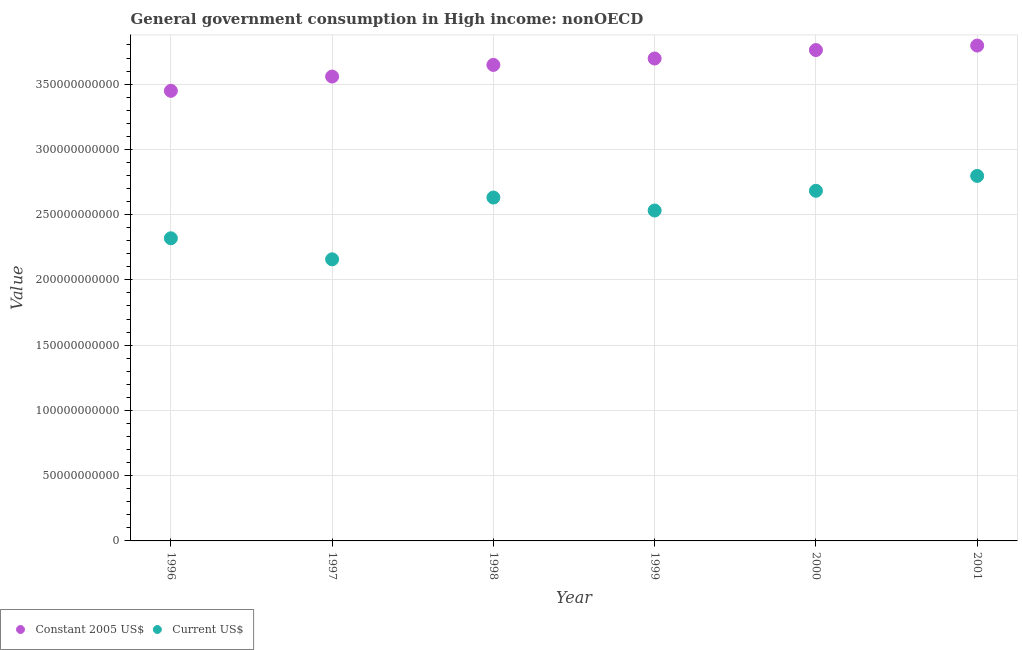Is the number of dotlines equal to the number of legend labels?
Ensure brevity in your answer.  Yes. What is the value consumed in current us$ in 1996?
Keep it short and to the point. 2.32e+11. Across all years, what is the maximum value consumed in constant 2005 us$?
Provide a succinct answer. 3.80e+11. Across all years, what is the minimum value consumed in constant 2005 us$?
Your response must be concise. 3.45e+11. In which year was the value consumed in constant 2005 us$ maximum?
Give a very brief answer. 2001. What is the total value consumed in constant 2005 us$ in the graph?
Your answer should be compact. 2.19e+12. What is the difference between the value consumed in current us$ in 1997 and that in 2001?
Offer a very short reply. -6.39e+1. What is the difference between the value consumed in constant 2005 us$ in 2001 and the value consumed in current us$ in 1996?
Your response must be concise. 1.48e+11. What is the average value consumed in current us$ per year?
Ensure brevity in your answer.  2.52e+11. In the year 2001, what is the difference between the value consumed in current us$ and value consumed in constant 2005 us$?
Keep it short and to the point. -9.99e+1. What is the ratio of the value consumed in current us$ in 1996 to that in 1997?
Provide a succinct answer. 1.07. Is the value consumed in constant 2005 us$ in 1997 less than that in 1999?
Your answer should be compact. Yes. What is the difference between the highest and the second highest value consumed in current us$?
Offer a terse response. 1.14e+1. What is the difference between the highest and the lowest value consumed in current us$?
Offer a terse response. 6.39e+1. Does the value consumed in constant 2005 us$ monotonically increase over the years?
Your answer should be very brief. Yes. Is the value consumed in current us$ strictly greater than the value consumed in constant 2005 us$ over the years?
Your response must be concise. No. Is the value consumed in constant 2005 us$ strictly less than the value consumed in current us$ over the years?
Offer a very short reply. No. What is the difference between two consecutive major ticks on the Y-axis?
Offer a terse response. 5.00e+1. Are the values on the major ticks of Y-axis written in scientific E-notation?
Your response must be concise. No. Does the graph contain any zero values?
Offer a terse response. No. How many legend labels are there?
Ensure brevity in your answer.  2. How are the legend labels stacked?
Make the answer very short. Horizontal. What is the title of the graph?
Give a very brief answer. General government consumption in High income: nonOECD. What is the label or title of the Y-axis?
Offer a very short reply. Value. What is the Value of Constant 2005 US$ in 1996?
Make the answer very short. 3.45e+11. What is the Value of Current US$ in 1996?
Give a very brief answer. 2.32e+11. What is the Value of Constant 2005 US$ in 1997?
Provide a short and direct response. 3.56e+11. What is the Value of Current US$ in 1997?
Make the answer very short. 2.16e+11. What is the Value in Constant 2005 US$ in 1998?
Keep it short and to the point. 3.65e+11. What is the Value in Current US$ in 1998?
Your answer should be very brief. 2.63e+11. What is the Value of Constant 2005 US$ in 1999?
Offer a terse response. 3.70e+11. What is the Value in Current US$ in 1999?
Provide a short and direct response. 2.53e+11. What is the Value of Constant 2005 US$ in 2000?
Make the answer very short. 3.76e+11. What is the Value of Current US$ in 2000?
Give a very brief answer. 2.68e+11. What is the Value in Constant 2005 US$ in 2001?
Your answer should be very brief. 3.80e+11. What is the Value in Current US$ in 2001?
Your answer should be very brief. 2.80e+11. Across all years, what is the maximum Value of Constant 2005 US$?
Give a very brief answer. 3.80e+11. Across all years, what is the maximum Value of Current US$?
Make the answer very short. 2.80e+11. Across all years, what is the minimum Value of Constant 2005 US$?
Provide a succinct answer. 3.45e+11. Across all years, what is the minimum Value of Current US$?
Ensure brevity in your answer.  2.16e+11. What is the total Value in Constant 2005 US$ in the graph?
Offer a terse response. 2.19e+12. What is the total Value of Current US$ in the graph?
Keep it short and to the point. 1.51e+12. What is the difference between the Value in Constant 2005 US$ in 1996 and that in 1997?
Offer a terse response. -1.09e+1. What is the difference between the Value in Current US$ in 1996 and that in 1997?
Ensure brevity in your answer.  1.61e+1. What is the difference between the Value in Constant 2005 US$ in 1996 and that in 1998?
Provide a short and direct response. -1.99e+1. What is the difference between the Value in Current US$ in 1996 and that in 1998?
Keep it short and to the point. -3.12e+1. What is the difference between the Value of Constant 2005 US$ in 1996 and that in 1999?
Offer a very short reply. -2.48e+1. What is the difference between the Value of Current US$ in 1996 and that in 1999?
Your answer should be very brief. -2.13e+1. What is the difference between the Value of Constant 2005 US$ in 1996 and that in 2000?
Your answer should be very brief. -3.12e+1. What is the difference between the Value in Current US$ in 1996 and that in 2000?
Ensure brevity in your answer.  -3.64e+1. What is the difference between the Value of Constant 2005 US$ in 1996 and that in 2001?
Make the answer very short. -3.47e+1. What is the difference between the Value of Current US$ in 1996 and that in 2001?
Keep it short and to the point. -4.78e+1. What is the difference between the Value of Constant 2005 US$ in 1997 and that in 1998?
Give a very brief answer. -8.92e+09. What is the difference between the Value of Current US$ in 1997 and that in 1998?
Offer a very short reply. -4.73e+1. What is the difference between the Value in Constant 2005 US$ in 1997 and that in 1999?
Make the answer very short. -1.38e+1. What is the difference between the Value of Current US$ in 1997 and that in 1999?
Your response must be concise. -3.74e+1. What is the difference between the Value in Constant 2005 US$ in 1997 and that in 2000?
Your response must be concise. -2.03e+1. What is the difference between the Value in Current US$ in 1997 and that in 2000?
Keep it short and to the point. -5.25e+1. What is the difference between the Value of Constant 2005 US$ in 1997 and that in 2001?
Give a very brief answer. -2.37e+1. What is the difference between the Value of Current US$ in 1997 and that in 2001?
Give a very brief answer. -6.39e+1. What is the difference between the Value in Constant 2005 US$ in 1998 and that in 1999?
Provide a succinct answer. -4.91e+09. What is the difference between the Value of Current US$ in 1998 and that in 1999?
Your response must be concise. 9.94e+09. What is the difference between the Value of Constant 2005 US$ in 1998 and that in 2000?
Offer a very short reply. -1.14e+1. What is the difference between the Value in Current US$ in 1998 and that in 2000?
Ensure brevity in your answer.  -5.17e+09. What is the difference between the Value of Constant 2005 US$ in 1998 and that in 2001?
Provide a succinct answer. -1.48e+1. What is the difference between the Value in Current US$ in 1998 and that in 2001?
Your response must be concise. -1.66e+1. What is the difference between the Value of Constant 2005 US$ in 1999 and that in 2000?
Ensure brevity in your answer.  -6.48e+09. What is the difference between the Value in Current US$ in 1999 and that in 2000?
Offer a very short reply. -1.51e+1. What is the difference between the Value in Constant 2005 US$ in 1999 and that in 2001?
Offer a very short reply. -9.92e+09. What is the difference between the Value of Current US$ in 1999 and that in 2001?
Your response must be concise. -2.65e+1. What is the difference between the Value in Constant 2005 US$ in 2000 and that in 2001?
Your answer should be very brief. -3.43e+09. What is the difference between the Value in Current US$ in 2000 and that in 2001?
Ensure brevity in your answer.  -1.14e+1. What is the difference between the Value in Constant 2005 US$ in 1996 and the Value in Current US$ in 1997?
Offer a very short reply. 1.29e+11. What is the difference between the Value in Constant 2005 US$ in 1996 and the Value in Current US$ in 1998?
Give a very brief answer. 8.18e+1. What is the difference between the Value in Constant 2005 US$ in 1996 and the Value in Current US$ in 1999?
Provide a succinct answer. 9.17e+1. What is the difference between the Value in Constant 2005 US$ in 1996 and the Value in Current US$ in 2000?
Give a very brief answer. 7.66e+1. What is the difference between the Value in Constant 2005 US$ in 1996 and the Value in Current US$ in 2001?
Keep it short and to the point. 6.52e+1. What is the difference between the Value in Constant 2005 US$ in 1997 and the Value in Current US$ in 1998?
Provide a succinct answer. 9.27e+1. What is the difference between the Value of Constant 2005 US$ in 1997 and the Value of Current US$ in 1999?
Provide a short and direct response. 1.03e+11. What is the difference between the Value of Constant 2005 US$ in 1997 and the Value of Current US$ in 2000?
Offer a very short reply. 8.75e+1. What is the difference between the Value of Constant 2005 US$ in 1997 and the Value of Current US$ in 2001?
Provide a short and direct response. 7.61e+1. What is the difference between the Value in Constant 2005 US$ in 1998 and the Value in Current US$ in 1999?
Provide a short and direct response. 1.12e+11. What is the difference between the Value in Constant 2005 US$ in 1998 and the Value in Current US$ in 2000?
Make the answer very short. 9.64e+1. What is the difference between the Value in Constant 2005 US$ in 1998 and the Value in Current US$ in 2001?
Provide a succinct answer. 8.50e+1. What is the difference between the Value in Constant 2005 US$ in 1999 and the Value in Current US$ in 2000?
Ensure brevity in your answer.  1.01e+11. What is the difference between the Value of Constant 2005 US$ in 1999 and the Value of Current US$ in 2001?
Ensure brevity in your answer.  9.00e+1. What is the difference between the Value of Constant 2005 US$ in 2000 and the Value of Current US$ in 2001?
Give a very brief answer. 9.64e+1. What is the average Value in Constant 2005 US$ per year?
Make the answer very short. 3.65e+11. What is the average Value of Current US$ per year?
Provide a short and direct response. 2.52e+11. In the year 1996, what is the difference between the Value of Constant 2005 US$ and Value of Current US$?
Provide a succinct answer. 1.13e+11. In the year 1997, what is the difference between the Value in Constant 2005 US$ and Value in Current US$?
Give a very brief answer. 1.40e+11. In the year 1998, what is the difference between the Value in Constant 2005 US$ and Value in Current US$?
Your answer should be compact. 1.02e+11. In the year 1999, what is the difference between the Value in Constant 2005 US$ and Value in Current US$?
Provide a short and direct response. 1.16e+11. In the year 2000, what is the difference between the Value in Constant 2005 US$ and Value in Current US$?
Provide a succinct answer. 1.08e+11. In the year 2001, what is the difference between the Value of Constant 2005 US$ and Value of Current US$?
Make the answer very short. 9.99e+1. What is the ratio of the Value in Constant 2005 US$ in 1996 to that in 1997?
Keep it short and to the point. 0.97. What is the ratio of the Value in Current US$ in 1996 to that in 1997?
Provide a succinct answer. 1.07. What is the ratio of the Value in Constant 2005 US$ in 1996 to that in 1998?
Keep it short and to the point. 0.95. What is the ratio of the Value of Current US$ in 1996 to that in 1998?
Your answer should be compact. 0.88. What is the ratio of the Value of Constant 2005 US$ in 1996 to that in 1999?
Give a very brief answer. 0.93. What is the ratio of the Value of Current US$ in 1996 to that in 1999?
Your answer should be very brief. 0.92. What is the ratio of the Value in Constant 2005 US$ in 1996 to that in 2000?
Make the answer very short. 0.92. What is the ratio of the Value in Current US$ in 1996 to that in 2000?
Offer a very short reply. 0.86. What is the ratio of the Value in Constant 2005 US$ in 1996 to that in 2001?
Offer a terse response. 0.91. What is the ratio of the Value in Current US$ in 1996 to that in 2001?
Ensure brevity in your answer.  0.83. What is the ratio of the Value in Constant 2005 US$ in 1997 to that in 1998?
Offer a terse response. 0.98. What is the ratio of the Value in Current US$ in 1997 to that in 1998?
Keep it short and to the point. 0.82. What is the ratio of the Value of Constant 2005 US$ in 1997 to that in 1999?
Provide a succinct answer. 0.96. What is the ratio of the Value in Current US$ in 1997 to that in 1999?
Keep it short and to the point. 0.85. What is the ratio of the Value in Constant 2005 US$ in 1997 to that in 2000?
Keep it short and to the point. 0.95. What is the ratio of the Value in Current US$ in 1997 to that in 2000?
Your answer should be very brief. 0.8. What is the ratio of the Value of Constant 2005 US$ in 1997 to that in 2001?
Your response must be concise. 0.94. What is the ratio of the Value of Current US$ in 1997 to that in 2001?
Offer a terse response. 0.77. What is the ratio of the Value in Constant 2005 US$ in 1998 to that in 1999?
Ensure brevity in your answer.  0.99. What is the ratio of the Value of Current US$ in 1998 to that in 1999?
Offer a very short reply. 1.04. What is the ratio of the Value of Constant 2005 US$ in 1998 to that in 2000?
Keep it short and to the point. 0.97. What is the ratio of the Value of Current US$ in 1998 to that in 2000?
Ensure brevity in your answer.  0.98. What is the ratio of the Value in Constant 2005 US$ in 1998 to that in 2001?
Your answer should be very brief. 0.96. What is the ratio of the Value of Current US$ in 1998 to that in 2001?
Make the answer very short. 0.94. What is the ratio of the Value of Constant 2005 US$ in 1999 to that in 2000?
Make the answer very short. 0.98. What is the ratio of the Value in Current US$ in 1999 to that in 2000?
Your response must be concise. 0.94. What is the ratio of the Value in Constant 2005 US$ in 1999 to that in 2001?
Ensure brevity in your answer.  0.97. What is the ratio of the Value of Current US$ in 1999 to that in 2001?
Give a very brief answer. 0.91. What is the ratio of the Value in Constant 2005 US$ in 2000 to that in 2001?
Keep it short and to the point. 0.99. What is the ratio of the Value in Current US$ in 2000 to that in 2001?
Ensure brevity in your answer.  0.96. What is the difference between the highest and the second highest Value of Constant 2005 US$?
Provide a short and direct response. 3.43e+09. What is the difference between the highest and the second highest Value of Current US$?
Offer a very short reply. 1.14e+1. What is the difference between the highest and the lowest Value of Constant 2005 US$?
Your response must be concise. 3.47e+1. What is the difference between the highest and the lowest Value of Current US$?
Make the answer very short. 6.39e+1. 